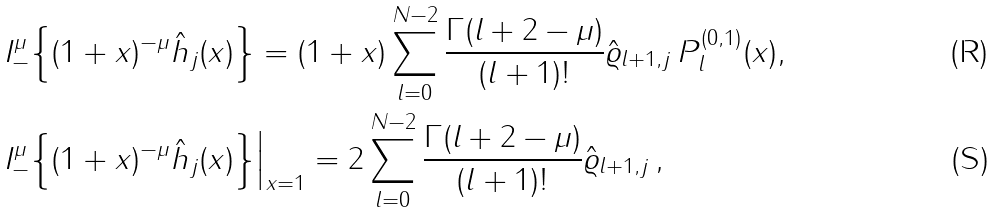<formula> <loc_0><loc_0><loc_500><loc_500>& I _ { - } ^ { \mu } \Big \{ ( 1 + x ) ^ { - \mu } \hat { h } _ { j } ( x ) \Big \} = ( 1 + x ) \sum _ { l = 0 } ^ { N - 2 } \frac { \Gamma ( l + 2 - \mu ) } { ( l + 1 ) ! } \hat { \varrho } _ { l + 1 , j } \, P _ { l } ^ { ( 0 , 1 ) } ( x ) , \\ & I _ { - } ^ { \mu } \Big \{ ( 1 + x ) ^ { - \mu } \hat { h } _ { j } ( x ) \Big \} \Big | _ { x = 1 } = 2 \sum _ { l = 0 } ^ { N - 2 } \frac { \Gamma ( l + 2 - \mu ) } { ( l + 1 ) ! } \hat { \varrho } _ { l + 1 , j } \, ,</formula> 